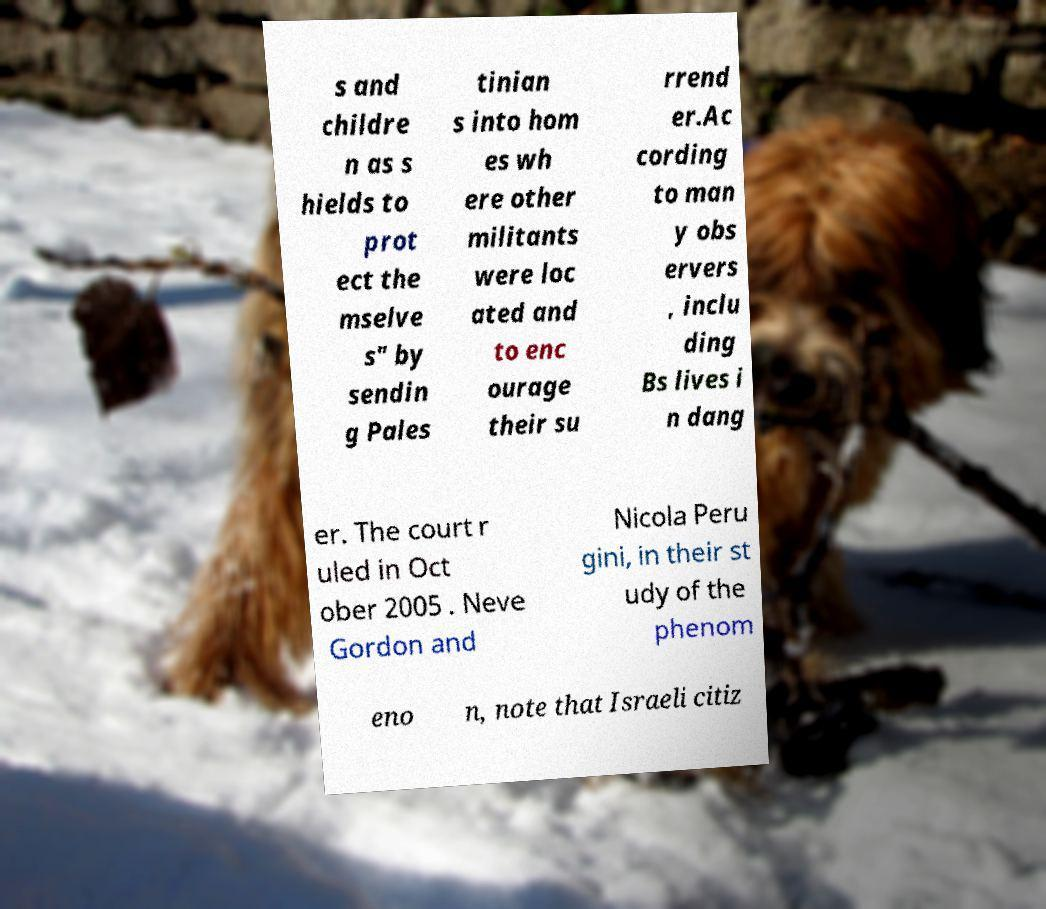Please read and relay the text visible in this image. What does it say? s and childre n as s hields to prot ect the mselve s" by sendin g Pales tinian s into hom es wh ere other militants were loc ated and to enc ourage their su rrend er.Ac cording to man y obs ervers , inclu ding Bs lives i n dang er. The court r uled in Oct ober 2005 . Neve Gordon and Nicola Peru gini, in their st udy of the phenom eno n, note that Israeli citiz 